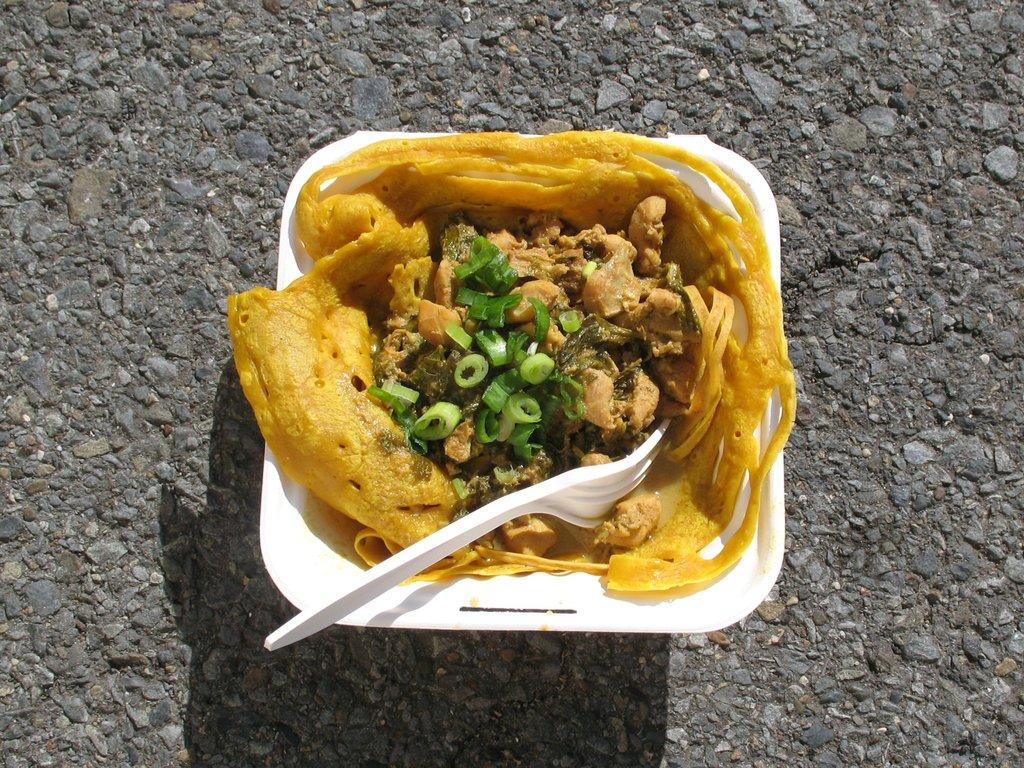What is in the image that can hold food? There is a serving bowl in the image. What is inside the serving bowl? The serving bowl contains food. What utensil is present in the serving bowl? There is a fork in the serving bowl. How does the earthquake affect the food in the serving bowl? There is no earthquake present in the image, so its effect on the food cannot be determined. 